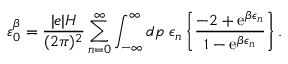Convert formula to latex. <formula><loc_0><loc_0><loc_500><loc_500>\varepsilon _ { 0 } ^ { \beta } = \frac { | e | H } { ( 2 \pi ) ^ { 2 } } \sum _ { n = 0 } ^ { \infty } \int _ { - \infty } ^ { \infty } d p \, \epsilon _ { n } \left \{ \frac { - 2 + e ^ { \beta \epsilon _ { n } } } { 1 - e ^ { \beta \epsilon _ { n } } } \right \} .</formula> 